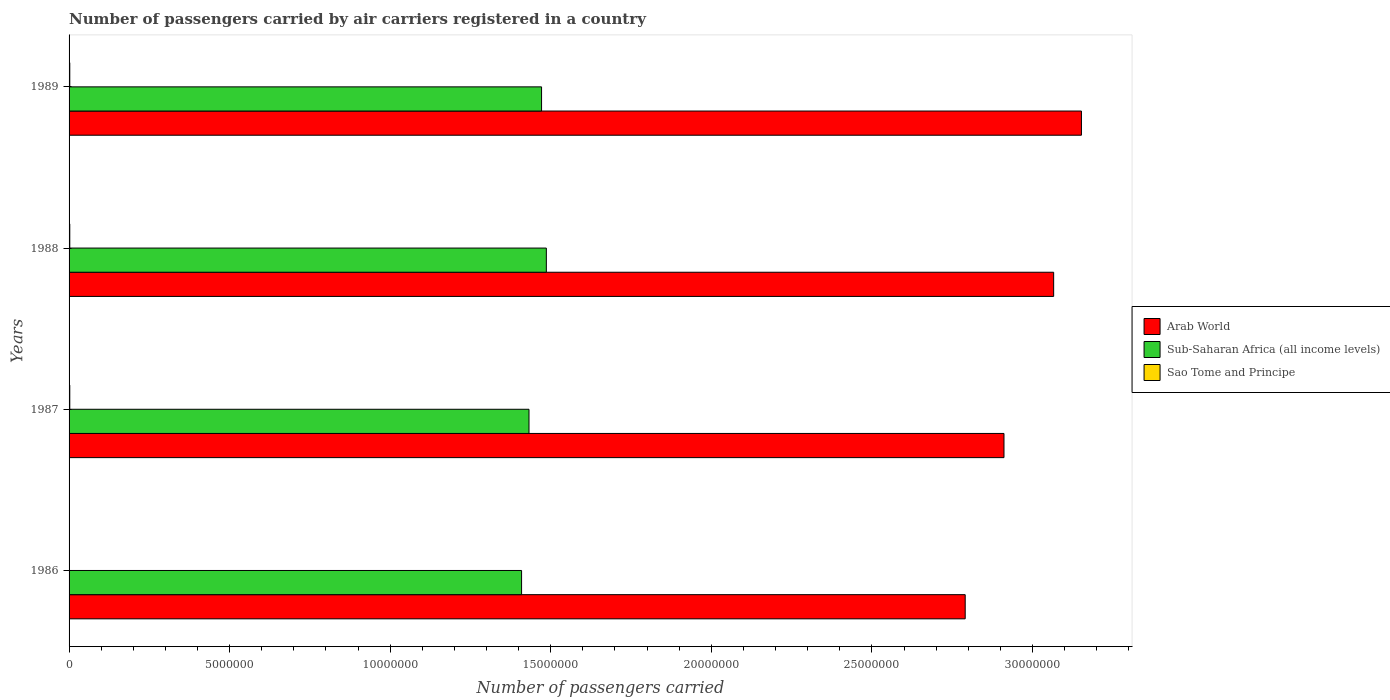How many groups of bars are there?
Make the answer very short. 4. Are the number of bars on each tick of the Y-axis equal?
Provide a short and direct response. Yes. What is the label of the 1st group of bars from the top?
Keep it short and to the point. 1989. What is the number of passengers carried by air carriers in Arab World in 1986?
Give a very brief answer. 2.79e+07. Across all years, what is the maximum number of passengers carried by air carriers in Sao Tome and Principe?
Your answer should be very brief. 2.23e+04. Across all years, what is the minimum number of passengers carried by air carriers in Sub-Saharan Africa (all income levels)?
Give a very brief answer. 1.41e+07. In which year was the number of passengers carried by air carriers in Sao Tome and Principe minimum?
Give a very brief answer. 1986. What is the total number of passengers carried by air carriers in Sao Tome and Principe in the graph?
Offer a very short reply. 7.53e+04. What is the difference between the number of passengers carried by air carriers in Sub-Saharan Africa (all income levels) in 1987 and that in 1989?
Your answer should be very brief. -3.91e+05. What is the difference between the number of passengers carried by air carriers in Sao Tome and Principe in 1987 and the number of passengers carried by air carriers in Arab World in 1988?
Ensure brevity in your answer.  -3.06e+07. What is the average number of passengers carried by air carriers in Arab World per year?
Make the answer very short. 2.98e+07. In the year 1989, what is the difference between the number of passengers carried by air carriers in Sao Tome and Principe and number of passengers carried by air carriers in Sub-Saharan Africa (all income levels)?
Your answer should be compact. -1.47e+07. What is the ratio of the number of passengers carried by air carriers in Arab World in 1986 to that in 1988?
Provide a short and direct response. 0.91. Is the difference between the number of passengers carried by air carriers in Sao Tome and Principe in 1988 and 1989 greater than the difference between the number of passengers carried by air carriers in Sub-Saharan Africa (all income levels) in 1988 and 1989?
Ensure brevity in your answer.  No. What is the difference between the highest and the second highest number of passengers carried by air carriers in Sao Tome and Principe?
Your answer should be very brief. 300. What is the difference between the highest and the lowest number of passengers carried by air carriers in Sao Tome and Principe?
Your answer should be compact. 1.33e+04. What does the 1st bar from the top in 1987 represents?
Your answer should be compact. Sao Tome and Principe. What does the 1st bar from the bottom in 1989 represents?
Your response must be concise. Arab World. Is it the case that in every year, the sum of the number of passengers carried by air carriers in Sub-Saharan Africa (all income levels) and number of passengers carried by air carriers in Arab World is greater than the number of passengers carried by air carriers in Sao Tome and Principe?
Your answer should be compact. Yes. Are all the bars in the graph horizontal?
Make the answer very short. Yes. How many years are there in the graph?
Your response must be concise. 4. What is the difference between two consecutive major ticks on the X-axis?
Provide a short and direct response. 5.00e+06. How are the legend labels stacked?
Provide a succinct answer. Vertical. What is the title of the graph?
Your answer should be compact. Number of passengers carried by air carriers registered in a country. Does "Bolivia" appear as one of the legend labels in the graph?
Offer a terse response. No. What is the label or title of the X-axis?
Provide a succinct answer. Number of passengers carried. What is the Number of passengers carried in Arab World in 1986?
Provide a succinct answer. 2.79e+07. What is the Number of passengers carried in Sub-Saharan Africa (all income levels) in 1986?
Your answer should be compact. 1.41e+07. What is the Number of passengers carried in Sao Tome and Principe in 1986?
Give a very brief answer. 9000. What is the Number of passengers carried in Arab World in 1987?
Your answer should be compact. 2.91e+07. What is the Number of passengers carried of Sub-Saharan Africa (all income levels) in 1987?
Your answer should be compact. 1.43e+07. What is the Number of passengers carried in Sao Tome and Principe in 1987?
Keep it short and to the point. 2.20e+04. What is the Number of passengers carried in Arab World in 1988?
Offer a terse response. 3.07e+07. What is the Number of passengers carried in Sub-Saharan Africa (all income levels) in 1988?
Your answer should be compact. 1.49e+07. What is the Number of passengers carried in Sao Tome and Principe in 1988?
Offer a very short reply. 2.20e+04. What is the Number of passengers carried in Arab World in 1989?
Make the answer very short. 3.15e+07. What is the Number of passengers carried of Sub-Saharan Africa (all income levels) in 1989?
Offer a terse response. 1.47e+07. What is the Number of passengers carried in Sao Tome and Principe in 1989?
Your answer should be compact. 2.23e+04. Across all years, what is the maximum Number of passengers carried of Arab World?
Provide a short and direct response. 3.15e+07. Across all years, what is the maximum Number of passengers carried of Sub-Saharan Africa (all income levels)?
Ensure brevity in your answer.  1.49e+07. Across all years, what is the maximum Number of passengers carried of Sao Tome and Principe?
Make the answer very short. 2.23e+04. Across all years, what is the minimum Number of passengers carried in Arab World?
Keep it short and to the point. 2.79e+07. Across all years, what is the minimum Number of passengers carried of Sub-Saharan Africa (all income levels)?
Your answer should be very brief. 1.41e+07. Across all years, what is the minimum Number of passengers carried of Sao Tome and Principe?
Your response must be concise. 9000. What is the total Number of passengers carried of Arab World in the graph?
Offer a very short reply. 1.19e+08. What is the total Number of passengers carried in Sub-Saharan Africa (all income levels) in the graph?
Ensure brevity in your answer.  5.80e+07. What is the total Number of passengers carried of Sao Tome and Principe in the graph?
Your answer should be very brief. 7.53e+04. What is the difference between the Number of passengers carried of Arab World in 1986 and that in 1987?
Make the answer very short. -1.21e+06. What is the difference between the Number of passengers carried of Sub-Saharan Africa (all income levels) in 1986 and that in 1987?
Your response must be concise. -2.32e+05. What is the difference between the Number of passengers carried in Sao Tome and Principe in 1986 and that in 1987?
Provide a succinct answer. -1.30e+04. What is the difference between the Number of passengers carried in Arab World in 1986 and that in 1988?
Your response must be concise. -2.75e+06. What is the difference between the Number of passengers carried in Sub-Saharan Africa (all income levels) in 1986 and that in 1988?
Keep it short and to the point. -7.71e+05. What is the difference between the Number of passengers carried of Sao Tome and Principe in 1986 and that in 1988?
Your response must be concise. -1.30e+04. What is the difference between the Number of passengers carried in Arab World in 1986 and that in 1989?
Your answer should be very brief. -3.62e+06. What is the difference between the Number of passengers carried in Sub-Saharan Africa (all income levels) in 1986 and that in 1989?
Your answer should be compact. -6.22e+05. What is the difference between the Number of passengers carried in Sao Tome and Principe in 1986 and that in 1989?
Your answer should be very brief. -1.33e+04. What is the difference between the Number of passengers carried in Arab World in 1987 and that in 1988?
Offer a very short reply. -1.55e+06. What is the difference between the Number of passengers carried of Sub-Saharan Africa (all income levels) in 1987 and that in 1988?
Provide a succinct answer. -5.40e+05. What is the difference between the Number of passengers carried in Arab World in 1987 and that in 1989?
Ensure brevity in your answer.  -2.41e+06. What is the difference between the Number of passengers carried in Sub-Saharan Africa (all income levels) in 1987 and that in 1989?
Your response must be concise. -3.91e+05. What is the difference between the Number of passengers carried of Sao Tome and Principe in 1987 and that in 1989?
Provide a short and direct response. -300. What is the difference between the Number of passengers carried in Arab World in 1988 and that in 1989?
Keep it short and to the point. -8.65e+05. What is the difference between the Number of passengers carried of Sub-Saharan Africa (all income levels) in 1988 and that in 1989?
Make the answer very short. 1.49e+05. What is the difference between the Number of passengers carried of Sao Tome and Principe in 1988 and that in 1989?
Offer a very short reply. -300. What is the difference between the Number of passengers carried of Arab World in 1986 and the Number of passengers carried of Sub-Saharan Africa (all income levels) in 1987?
Your response must be concise. 1.36e+07. What is the difference between the Number of passengers carried of Arab World in 1986 and the Number of passengers carried of Sao Tome and Principe in 1987?
Make the answer very short. 2.79e+07. What is the difference between the Number of passengers carried in Sub-Saharan Africa (all income levels) in 1986 and the Number of passengers carried in Sao Tome and Principe in 1987?
Ensure brevity in your answer.  1.41e+07. What is the difference between the Number of passengers carried of Arab World in 1986 and the Number of passengers carried of Sub-Saharan Africa (all income levels) in 1988?
Your answer should be very brief. 1.30e+07. What is the difference between the Number of passengers carried of Arab World in 1986 and the Number of passengers carried of Sao Tome and Principe in 1988?
Keep it short and to the point. 2.79e+07. What is the difference between the Number of passengers carried in Sub-Saharan Africa (all income levels) in 1986 and the Number of passengers carried in Sao Tome and Principe in 1988?
Ensure brevity in your answer.  1.41e+07. What is the difference between the Number of passengers carried in Arab World in 1986 and the Number of passengers carried in Sub-Saharan Africa (all income levels) in 1989?
Keep it short and to the point. 1.32e+07. What is the difference between the Number of passengers carried in Arab World in 1986 and the Number of passengers carried in Sao Tome and Principe in 1989?
Your response must be concise. 2.79e+07. What is the difference between the Number of passengers carried in Sub-Saharan Africa (all income levels) in 1986 and the Number of passengers carried in Sao Tome and Principe in 1989?
Your answer should be very brief. 1.41e+07. What is the difference between the Number of passengers carried in Arab World in 1987 and the Number of passengers carried in Sub-Saharan Africa (all income levels) in 1988?
Provide a short and direct response. 1.43e+07. What is the difference between the Number of passengers carried in Arab World in 1987 and the Number of passengers carried in Sao Tome and Principe in 1988?
Offer a terse response. 2.91e+07. What is the difference between the Number of passengers carried in Sub-Saharan Africa (all income levels) in 1987 and the Number of passengers carried in Sao Tome and Principe in 1988?
Provide a short and direct response. 1.43e+07. What is the difference between the Number of passengers carried of Arab World in 1987 and the Number of passengers carried of Sub-Saharan Africa (all income levels) in 1989?
Your answer should be very brief. 1.44e+07. What is the difference between the Number of passengers carried in Arab World in 1987 and the Number of passengers carried in Sao Tome and Principe in 1989?
Make the answer very short. 2.91e+07. What is the difference between the Number of passengers carried in Sub-Saharan Africa (all income levels) in 1987 and the Number of passengers carried in Sao Tome and Principe in 1989?
Your answer should be compact. 1.43e+07. What is the difference between the Number of passengers carried of Arab World in 1988 and the Number of passengers carried of Sub-Saharan Africa (all income levels) in 1989?
Your answer should be compact. 1.59e+07. What is the difference between the Number of passengers carried in Arab World in 1988 and the Number of passengers carried in Sao Tome and Principe in 1989?
Your response must be concise. 3.06e+07. What is the difference between the Number of passengers carried of Sub-Saharan Africa (all income levels) in 1988 and the Number of passengers carried of Sao Tome and Principe in 1989?
Offer a very short reply. 1.48e+07. What is the average Number of passengers carried in Arab World per year?
Your answer should be very brief. 2.98e+07. What is the average Number of passengers carried of Sub-Saharan Africa (all income levels) per year?
Your response must be concise. 1.45e+07. What is the average Number of passengers carried of Sao Tome and Principe per year?
Offer a very short reply. 1.88e+04. In the year 1986, what is the difference between the Number of passengers carried of Arab World and Number of passengers carried of Sub-Saharan Africa (all income levels)?
Offer a very short reply. 1.38e+07. In the year 1986, what is the difference between the Number of passengers carried in Arab World and Number of passengers carried in Sao Tome and Principe?
Give a very brief answer. 2.79e+07. In the year 1986, what is the difference between the Number of passengers carried in Sub-Saharan Africa (all income levels) and Number of passengers carried in Sao Tome and Principe?
Ensure brevity in your answer.  1.41e+07. In the year 1987, what is the difference between the Number of passengers carried of Arab World and Number of passengers carried of Sub-Saharan Africa (all income levels)?
Your answer should be very brief. 1.48e+07. In the year 1987, what is the difference between the Number of passengers carried of Arab World and Number of passengers carried of Sao Tome and Principe?
Your response must be concise. 2.91e+07. In the year 1987, what is the difference between the Number of passengers carried in Sub-Saharan Africa (all income levels) and Number of passengers carried in Sao Tome and Principe?
Your answer should be very brief. 1.43e+07. In the year 1988, what is the difference between the Number of passengers carried in Arab World and Number of passengers carried in Sub-Saharan Africa (all income levels)?
Offer a very short reply. 1.58e+07. In the year 1988, what is the difference between the Number of passengers carried of Arab World and Number of passengers carried of Sao Tome and Principe?
Make the answer very short. 3.06e+07. In the year 1988, what is the difference between the Number of passengers carried of Sub-Saharan Africa (all income levels) and Number of passengers carried of Sao Tome and Principe?
Your response must be concise. 1.48e+07. In the year 1989, what is the difference between the Number of passengers carried in Arab World and Number of passengers carried in Sub-Saharan Africa (all income levels)?
Offer a very short reply. 1.68e+07. In the year 1989, what is the difference between the Number of passengers carried in Arab World and Number of passengers carried in Sao Tome and Principe?
Keep it short and to the point. 3.15e+07. In the year 1989, what is the difference between the Number of passengers carried in Sub-Saharan Africa (all income levels) and Number of passengers carried in Sao Tome and Principe?
Ensure brevity in your answer.  1.47e+07. What is the ratio of the Number of passengers carried of Arab World in 1986 to that in 1987?
Your answer should be very brief. 0.96. What is the ratio of the Number of passengers carried in Sub-Saharan Africa (all income levels) in 1986 to that in 1987?
Your answer should be compact. 0.98. What is the ratio of the Number of passengers carried in Sao Tome and Principe in 1986 to that in 1987?
Offer a very short reply. 0.41. What is the ratio of the Number of passengers carried of Arab World in 1986 to that in 1988?
Offer a very short reply. 0.91. What is the ratio of the Number of passengers carried in Sub-Saharan Africa (all income levels) in 1986 to that in 1988?
Offer a very short reply. 0.95. What is the ratio of the Number of passengers carried of Sao Tome and Principe in 1986 to that in 1988?
Ensure brevity in your answer.  0.41. What is the ratio of the Number of passengers carried of Arab World in 1986 to that in 1989?
Ensure brevity in your answer.  0.89. What is the ratio of the Number of passengers carried in Sub-Saharan Africa (all income levels) in 1986 to that in 1989?
Provide a succinct answer. 0.96. What is the ratio of the Number of passengers carried in Sao Tome and Principe in 1986 to that in 1989?
Keep it short and to the point. 0.4. What is the ratio of the Number of passengers carried in Arab World in 1987 to that in 1988?
Ensure brevity in your answer.  0.95. What is the ratio of the Number of passengers carried of Sub-Saharan Africa (all income levels) in 1987 to that in 1988?
Your answer should be very brief. 0.96. What is the ratio of the Number of passengers carried in Sao Tome and Principe in 1987 to that in 1988?
Your answer should be very brief. 1. What is the ratio of the Number of passengers carried of Arab World in 1987 to that in 1989?
Give a very brief answer. 0.92. What is the ratio of the Number of passengers carried of Sub-Saharan Africa (all income levels) in 1987 to that in 1989?
Make the answer very short. 0.97. What is the ratio of the Number of passengers carried of Sao Tome and Principe in 1987 to that in 1989?
Ensure brevity in your answer.  0.99. What is the ratio of the Number of passengers carried of Arab World in 1988 to that in 1989?
Provide a short and direct response. 0.97. What is the ratio of the Number of passengers carried in Sao Tome and Principe in 1988 to that in 1989?
Ensure brevity in your answer.  0.99. What is the difference between the highest and the second highest Number of passengers carried of Arab World?
Your answer should be very brief. 8.65e+05. What is the difference between the highest and the second highest Number of passengers carried in Sub-Saharan Africa (all income levels)?
Make the answer very short. 1.49e+05. What is the difference between the highest and the second highest Number of passengers carried in Sao Tome and Principe?
Your answer should be compact. 300. What is the difference between the highest and the lowest Number of passengers carried in Arab World?
Make the answer very short. 3.62e+06. What is the difference between the highest and the lowest Number of passengers carried in Sub-Saharan Africa (all income levels)?
Provide a succinct answer. 7.71e+05. What is the difference between the highest and the lowest Number of passengers carried of Sao Tome and Principe?
Make the answer very short. 1.33e+04. 